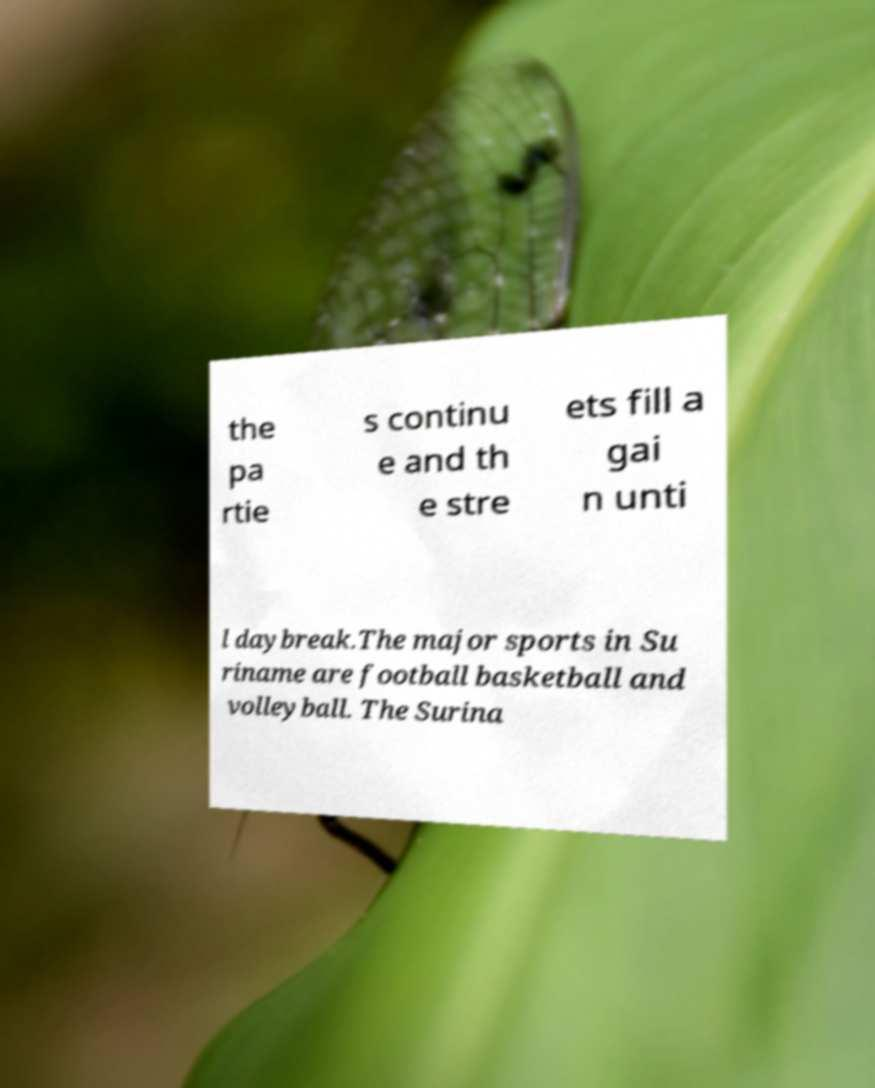Please read and relay the text visible in this image. What does it say? the pa rtie s continu e and th e stre ets fill a gai n unti l daybreak.The major sports in Su riname are football basketball and volleyball. The Surina 